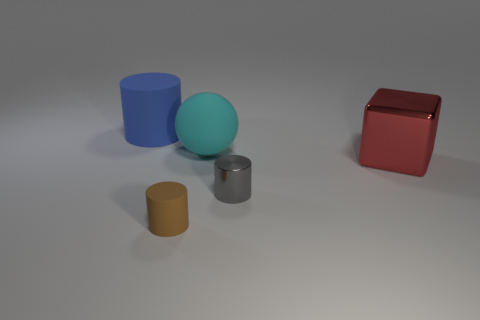Add 4 rubber things. How many objects exist? 9 Subtract all cylinders. How many objects are left? 2 Add 3 big cylinders. How many big cylinders are left? 4 Add 4 large cyan metal balls. How many large cyan metal balls exist? 4 Subtract 0 yellow balls. How many objects are left? 5 Subtract all red spheres. Subtract all big blue rubber objects. How many objects are left? 4 